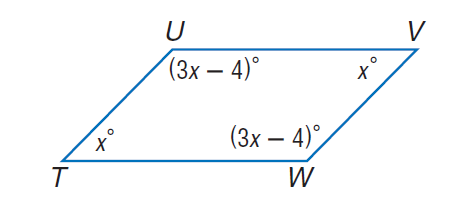Answer the mathemtical geometry problem and directly provide the correct option letter.
Question: Find \angle W.
Choices: A: 44 B: 46 C: 54 D: 134 D 